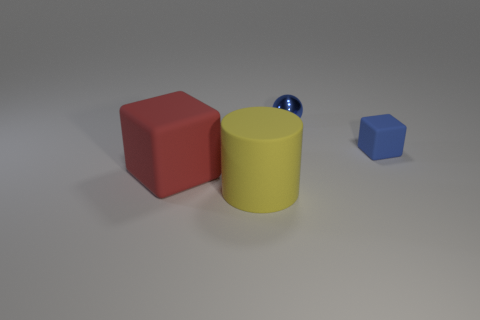Add 2 red shiny spheres. How many objects exist? 6 Subtract all cylinders. How many objects are left? 3 Subtract 1 blue cubes. How many objects are left? 3 Subtract all cylinders. Subtract all yellow rubber cylinders. How many objects are left? 2 Add 2 yellow objects. How many yellow objects are left? 3 Add 4 big purple rubber things. How many big purple rubber things exist? 4 